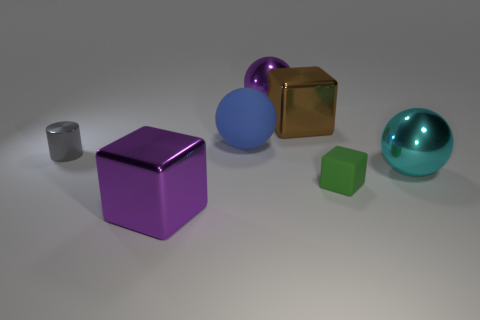Subtract all big metal balls. How many balls are left? 1 Add 3 rubber spheres. How many objects exist? 10 Subtract all cylinders. How many objects are left? 6 Subtract all red cylinders. Subtract all green balls. How many cylinders are left? 1 Subtract all tiny cylinders. Subtract all big purple metallic blocks. How many objects are left? 5 Add 3 green blocks. How many green blocks are left? 4 Add 4 small green matte things. How many small green matte things exist? 5 Subtract 1 green cubes. How many objects are left? 6 